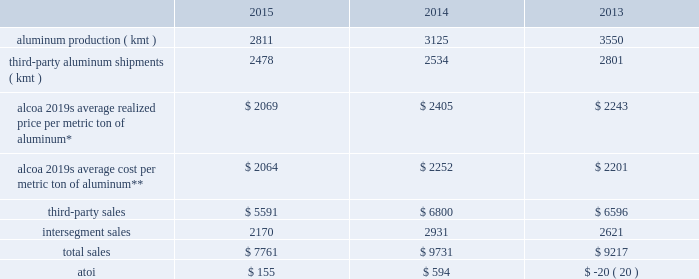In 2016 , alumina production will be approximately 2500 kmt lower , mostly due to the curtailment of the point comfort and suralco refineries .
Also , the continued shift towards alumina index and spot pricing is expected to average 85% ( 85 % ) of third-party smelter-grade alumina shipments .
Additionally , net productivity improvements are anticipated .
Primary metals .
* average realized price per metric ton of aluminum includes three elements : a ) the underlying base metal component , based on quoted prices from the lme ; b ) the regional premium , which represents the incremental price over the base lme component that is associated with the physical delivery of metal to a particular region ( e.g. , the midwest premium for metal sold in the united states ) ; and c ) the product premium , which represents the incremental price for receiving physical metal in a particular shape ( e.g. , billet , slab , rod , etc. ) or alloy .
**includes all production-related costs , including raw materials consumed ; conversion costs , such as labor , materials , and utilities ; depreciation and amortization ; and plant administrative expenses .
This segment represents a portion of alcoa 2019s upstream operations and consists of the company 2019s worldwide smelting system .
Primary metals purchases alumina , mostly from the alumina segment ( see alumina above ) , from which primary aluminum is produced and then sold directly to external customers and traders , as well as to alcoa 2019s midstream operations and , to a lesser extent , downstream operations .
Results from the sale of aluminum powder , scrap , and excess energy are also included in this segment , as well as the results of aluminum derivative contracts and buy/ resell activity .
Primary aluminum produced by alcoa and used internally is transferred to other segments at prevailing market prices .
The sale of primary aluminum represents approximately 90% ( 90 % ) of this segment 2019s third-party sales .
Buy/ resell activity occurs when this segment purchases metal and resells such metal to external customers or the midstream and downstream operations in order to maximize smelting system efficiency and to meet customer requirements .
Generally , the sales of this segment are transacted in u.s .
Dollars while costs and expenses of this segment are transacted in the local currency of the respective operations , which are the u.s .
Dollar , the euro , the norwegian kroner , icelandic krona , the canadian dollar , the brazilian real , and the australian dollar .
In november 2014 , alcoa completed the sale of an aluminum rod plant located in b e9cancour , qu e9bec , canada to sural laminated products .
This facility takes molten aluminum and shapes it into the form of a rod , which is used by customers primarily for the transportation of electricity .
While owned by alcoa , the operating results and assets and liabilities of this plant were included in the primary metals segment .
In conjunction with this transaction , alcoa entered into a multi-year agreement with sural laminated products to supply molten aluminum for the rod plant .
The aluminum rod plant generated sales of approximately $ 200 in 2013 and , at the time of divestiture , had approximately 60 employees .
See restructuring and other charges in results of operations above .
In december 2014 , alcoa completed the sale of its 50.33% ( 50.33 % ) ownership stake in the mt .
Holly smelter located in goose creek , south carolina to century aluminum company .
While owned by alcoa , 50.33% ( 50.33 % ) of both the operating results and assets and liabilities related to the smelter were included in the primary metals segment .
As it relates to alcoa 2019s previous 50.33% ( 50.33 % ) ownership stake , the smelter ( alcoa 2019s share of the capacity was 115 kmt-per-year ) generated sales of approximately $ 280 in 2013 and , at the time of divestiture , had approximately 250 employees .
See restructuring and other charges in results of operations above .
At december 31 , 2015 , alcoa had 778 kmt of idle capacity on a base capacity of 3401 kmt .
In 2015 , idle capacity increased 113 kmt compared to 2014 , mostly due to the curtailment of 217 kmt combined at a smelter in each the .
What was the number of dollars obtained with the sale of primary aluminum in 2015? 
Rationale: it is the number of third-party sales multiplied by 90% .
Computations: (90% * 5591)
Answer: 5031.9. 